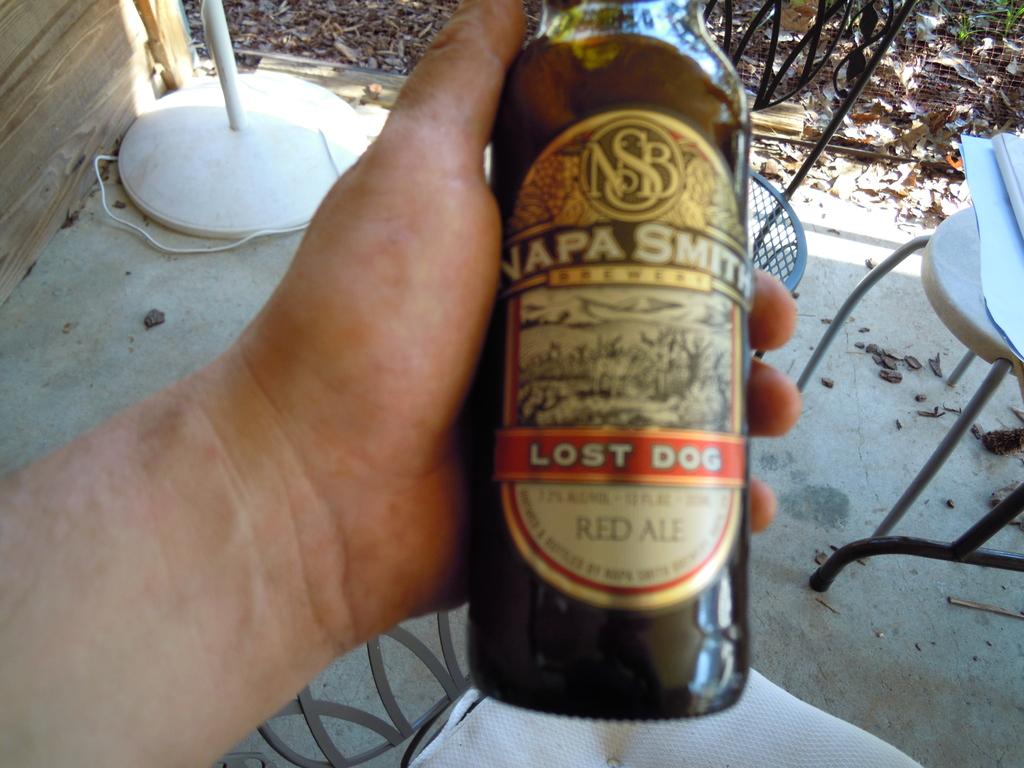What is the name of this drink?
Make the answer very short. Lost dog. 